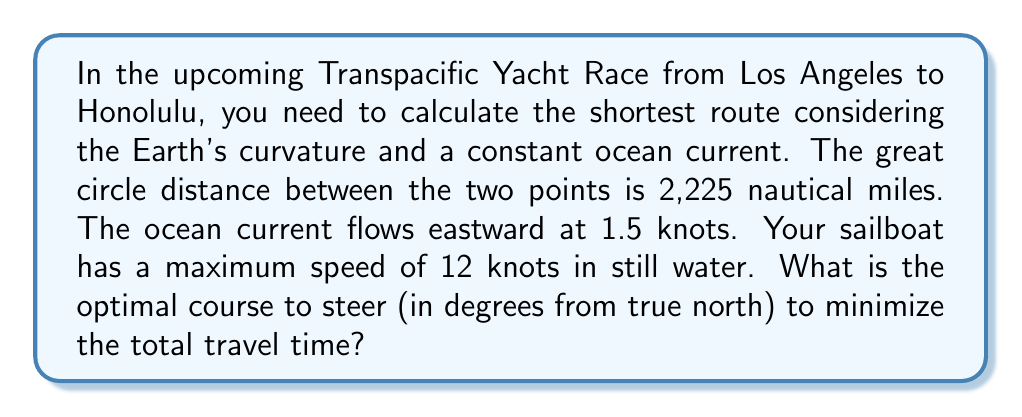Give your solution to this math problem. To solve this problem, we need to consider the effect of the ocean current on the boat's velocity and use vector algebra to find the optimal course. Let's break it down step by step:

1. Define variables:
   $v_b$ = boat speed in still water = 12 knots
   $v_c$ = current speed = 1.5 knots
   $d$ = great circle distance = 2,225 nautical miles

2. The boat's velocity relative to the water ($\vec{v_b}$) and the current velocity ($\vec{v_c}$) form a vector triangle with the resulting ground velocity ($\vec{v_g}$).

3. Let $\theta$ be the angle between the boat's heading and the rhumb line (great circle route). We want to find the optimal $\theta$ that minimizes travel time.

4. The ground speed can be calculated using the law of cosines:
   $$v_g = \sqrt{v_b^2 + v_c^2 - 2v_bv_c\cos(90^\circ + \theta)}$$

5. The time of travel is given by:
   $$t = \frac{d}{v_g}$$

6. To minimize travel time, we need to maximize $v_g$. Taking the derivative of $v_g$ with respect to $\theta$ and setting it to zero:
   $$\frac{d}{d\theta}v_g = 0$$

7. Solving this equation leads to:
   $$\sin\theta = \frac{v_c}{v_b}$$

8. Therefore, the optimal angle $\theta$ is:
   $$\theta = \arcsin(\frac{v_c}{v_b}) = \arcsin(\frac{1.5}{12}) \approx 7.18^\circ$$

9. The course to steer is 90° - θ from true north, as the current is flowing eastward:
   $$\text{Course} = 90^\circ - 7.18^\circ = 82.82^\circ$$

This course will allow the boat to maintain the great circle route while compensating for the ocean current, minimizing the total travel time.
Answer: 82.82° from true north 